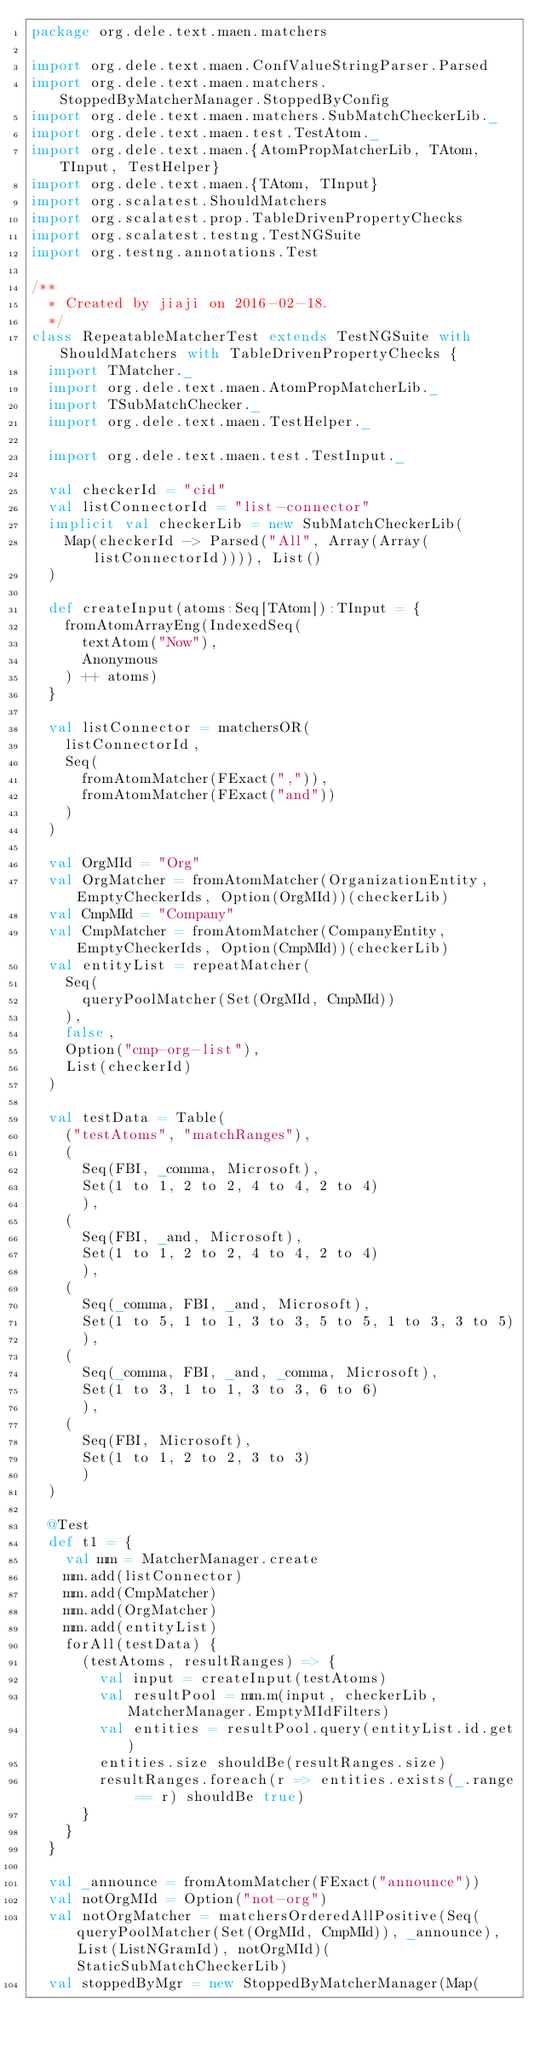<code> <loc_0><loc_0><loc_500><loc_500><_Scala_>package org.dele.text.maen.matchers

import org.dele.text.maen.ConfValueStringParser.Parsed
import org.dele.text.maen.matchers.StoppedByMatcherManager.StoppedByConfig
import org.dele.text.maen.matchers.SubMatchCheckerLib._
import org.dele.text.maen.test.TestAtom._
import org.dele.text.maen.{AtomPropMatcherLib, TAtom, TInput, TestHelper}
import org.dele.text.maen.{TAtom, TInput}
import org.scalatest.ShouldMatchers
import org.scalatest.prop.TableDrivenPropertyChecks
import org.scalatest.testng.TestNGSuite
import org.testng.annotations.Test

/**
  * Created by jiaji on 2016-02-18.
  */
class RepeatableMatcherTest extends TestNGSuite with ShouldMatchers with TableDrivenPropertyChecks {
  import TMatcher._
  import org.dele.text.maen.AtomPropMatcherLib._
  import TSubMatchChecker._
  import org.dele.text.maen.TestHelper._

  import org.dele.text.maen.test.TestInput._

  val checkerId = "cid"
  val listConnectorId = "list-connector"
  implicit val checkerLib = new SubMatchCheckerLib(
    Map(checkerId -> Parsed("All", Array(Array(listConnectorId)))), List()
  )

  def createInput(atoms:Seq[TAtom]):TInput = {
    fromAtomArrayEng(IndexedSeq(
      textAtom("Now"),
      Anonymous
    ) ++ atoms)
  }

  val listConnector = matchersOR(
    listConnectorId,
    Seq(
      fromAtomMatcher(FExact(",")),
      fromAtomMatcher(FExact("and"))
    )
  )

  val OrgMId = "Org"
  val OrgMatcher = fromAtomMatcher(OrganizationEntity, EmptyCheckerIds, Option(OrgMId))(checkerLib)
  val CmpMId = "Company"
  val CmpMatcher = fromAtomMatcher(CompanyEntity, EmptyCheckerIds, Option(CmpMId))(checkerLib)
  val entityList = repeatMatcher(
    Seq(
      queryPoolMatcher(Set(OrgMId, CmpMId))
    ),
    false,
    Option("cmp-org-list"),
    List(checkerId)
  )

  val testData = Table(
    ("testAtoms", "matchRanges"),
    (
      Seq(FBI, _comma, Microsoft),
      Set(1 to 1, 2 to 2, 4 to 4, 2 to 4)
      ),
    (
      Seq(FBI, _and, Microsoft),
      Set(1 to 1, 2 to 2, 4 to 4, 2 to 4)
      ),
    (
      Seq(_comma, FBI, _and, Microsoft),
      Set(1 to 5, 1 to 1, 3 to 3, 5 to 5, 1 to 3, 3 to 5)
      ),
    (
      Seq(_comma, FBI, _and, _comma, Microsoft),
      Set(1 to 3, 1 to 1, 3 to 3, 6 to 6)
      ),
    (
      Seq(FBI, Microsoft),
      Set(1 to 1, 2 to 2, 3 to 3)
      )
  )

  @Test
  def t1 = {
    val mm = MatcherManager.create
    mm.add(listConnector)
    mm.add(CmpMatcher)
    mm.add(OrgMatcher)
    mm.add(entityList)
    forAll(testData) {
      (testAtoms, resultRanges) => {
        val input = createInput(testAtoms)
        val resultPool = mm.m(input, checkerLib, MatcherManager.EmptyMIdFilters)
        val entities = resultPool.query(entityList.id.get)
        entities.size shouldBe(resultRanges.size)
        resultRanges.foreach(r => entities.exists(_.range == r) shouldBe true)
      }
    }
  }

  val _announce = fromAtomMatcher(FExact("announce"))
  val notOrgMId = Option("not-org")
  val notOrgMatcher = matchersOrderedAllPositive(Seq(queryPoolMatcher(Set(OrgMId, CmpMId)), _announce), List(ListNGramId), notOrgMId)(StaticSubMatchCheckerLib)
  val stoppedByMgr = new StoppedByMatcherManager(Map(</code> 